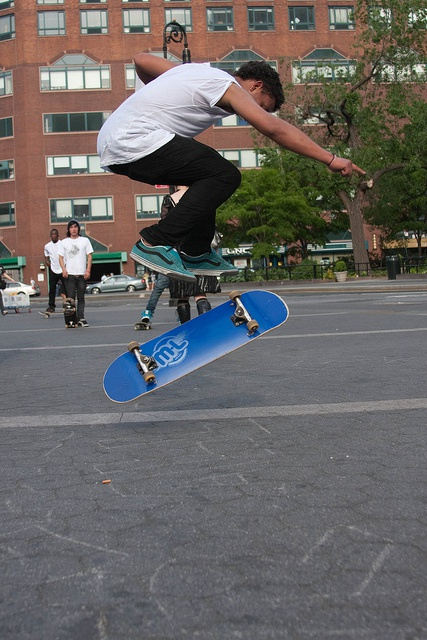Describe the objects in this image and their specific colors. I can see people in lightgray, black, lavender, brown, and darkgray tones, skateboard in lightgray, blue, gray, and darkgray tones, people in lightgray, black, gray, and brown tones, people in lightgray, black, lavender, maroon, and gray tones, and car in lightgray, darkgray, gray, and black tones in this image. 